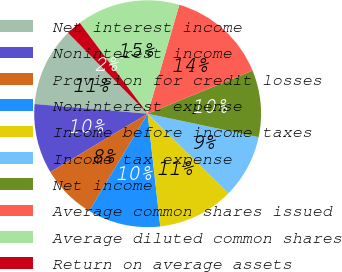<chart> <loc_0><loc_0><loc_500><loc_500><pie_chart><fcel>Net interest income<fcel>Noninterest income<fcel>Provision for credit losses<fcel>Noninterest expense<fcel>Income before income taxes<fcel>Income tax expense<fcel>Net income<fcel>Average common shares issued<fcel>Average diluted common shares<fcel>Return on average assets<nl><fcel>11.26%<fcel>9.96%<fcel>7.79%<fcel>10.39%<fcel>10.82%<fcel>9.09%<fcel>9.52%<fcel>14.29%<fcel>14.72%<fcel>2.16%<nl></chart> 